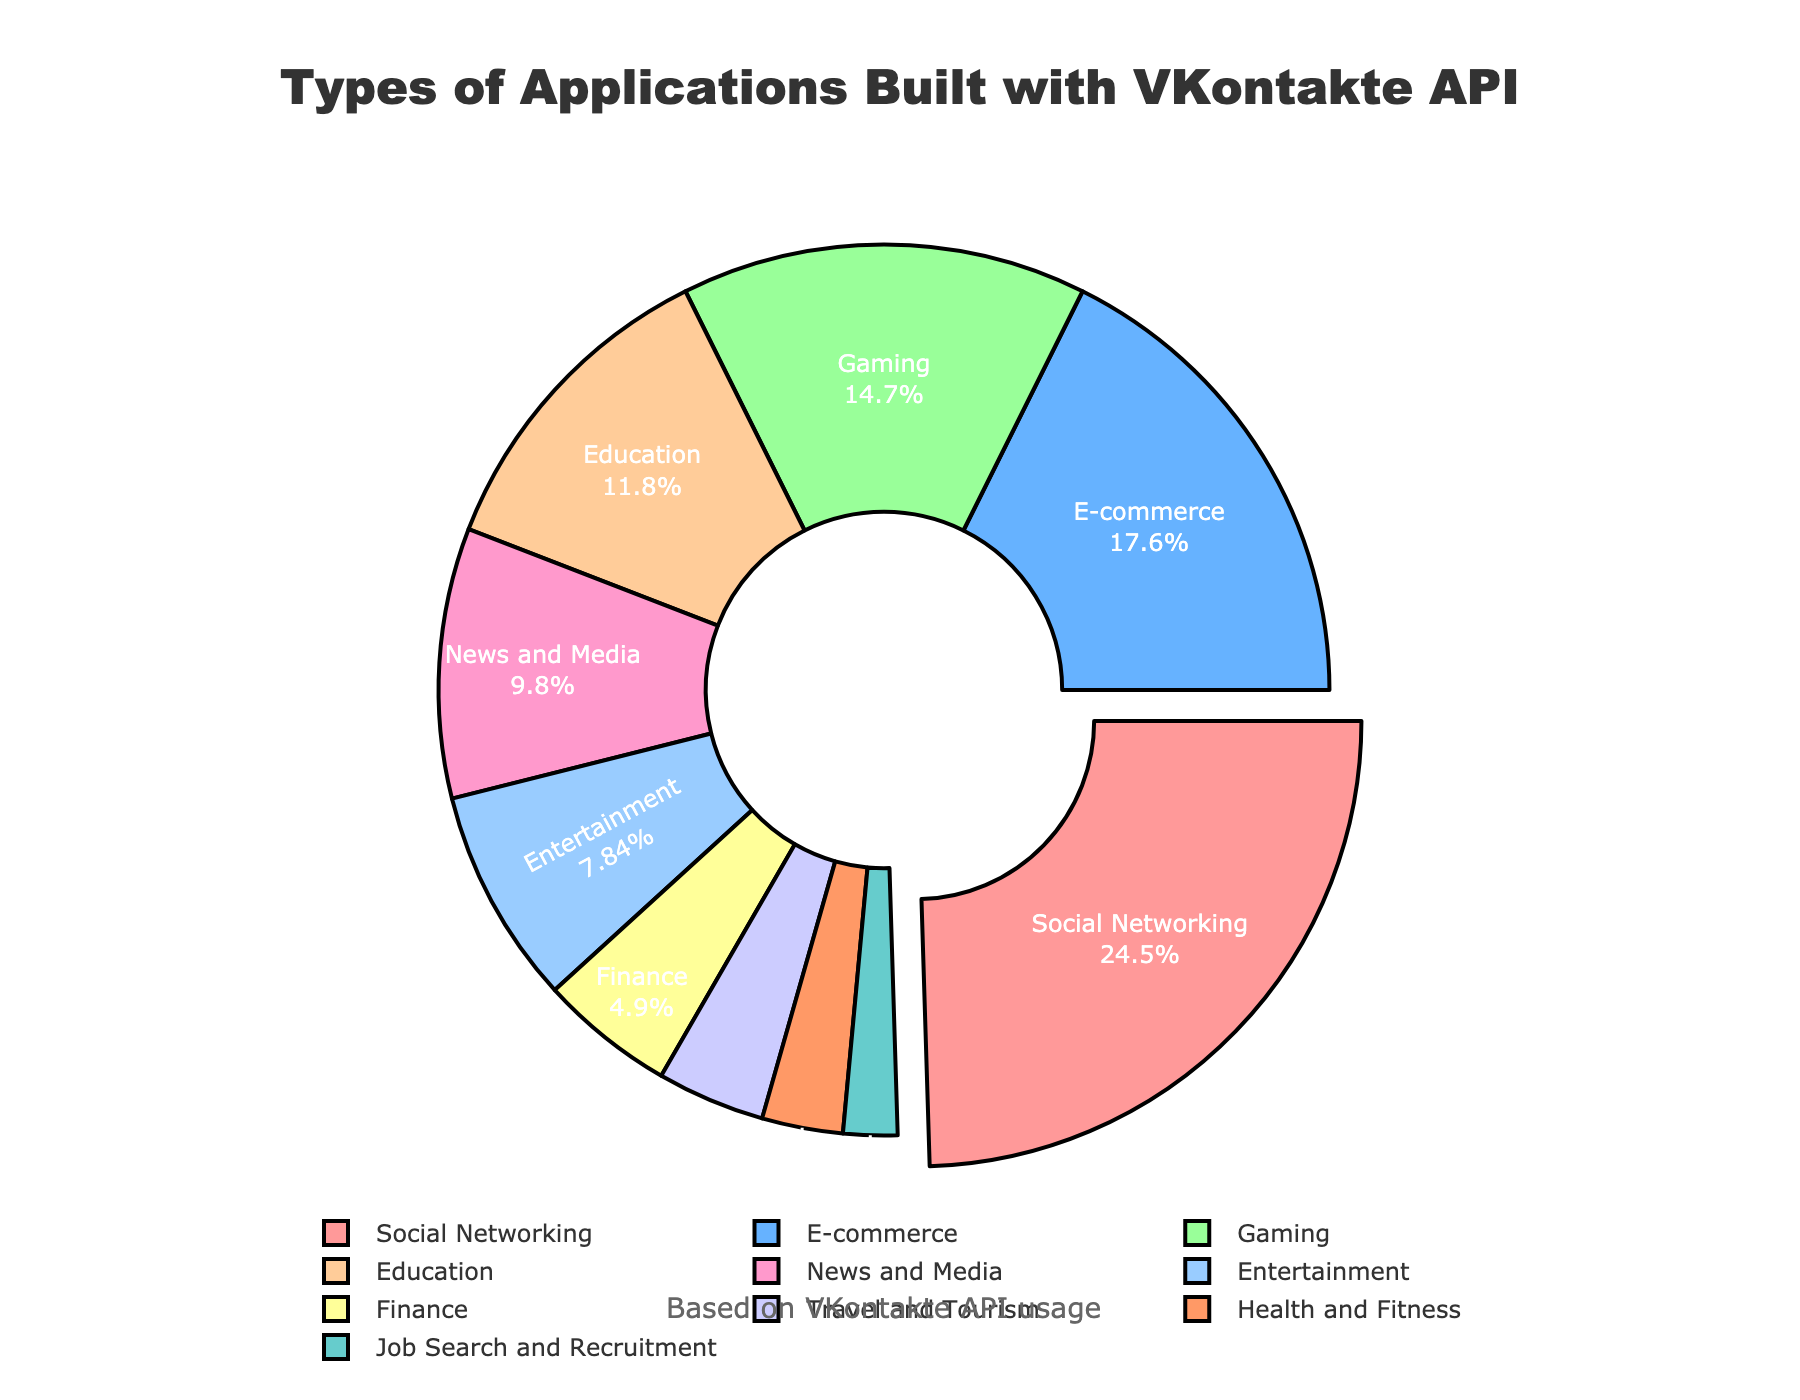What percentage of applications are built for the Social Networking sector? The Social Networking sector occupies 25% of the pie chart.
Answer: 25% Which industry sector has the smallest percentage of applications built with VKontakte API? The Job Search and Recruitment sector has the smallest percentage, which is 2%.
Answer: Job Search and Recruitment How much greater is the percentage of Social Networking applications compared to Health and Fitness applications? Social Networking applications are 25%, and Health and Fitness applications are 3%. The difference is 25% - 3% = 22%.
Answer: 22% What is the combined percentage of applications built for the Gaming and Education sectors? The Gaming sector is 15%, and the Education sector is 12%. Combined, they account for 15% + 12% = 27%.
Answer: 27% Which industry sectors are represented by the colors red and green? The red color represents the Social Networking sector, and the green color represents the Gaming sector.
Answer: Social Networking and Gaming What is the percentage difference between E-commerce and Entertainment applications? E-commerce applications are 18%, and Entertainment applications are 8%. The difference is 18% - 8% = 10%.
Answer: 10% How many sectors have a percentage of 10% or higher? Social Networking (25%), E-commerce (18%), Gaming (15%), Education (12%), and News and Media (10%) each have 10% or higher. This totals 5 sectors.
Answer: 5 What percentage of all applications falls under sectors with less than 5%? Finance (5%), Travel and Tourism (4%), Health and Fitness (3%), and Job Search and Recruitment (2%) each have less than 5%. Their total is 5% + 4% + 3% + 2% = 14%.
Answer: 14% Which sector is pulled out slightly from the pie chart, and why? The Social Networking sector is pulled out because it has the highest percentage at 25%.
Answer: Social Networking 